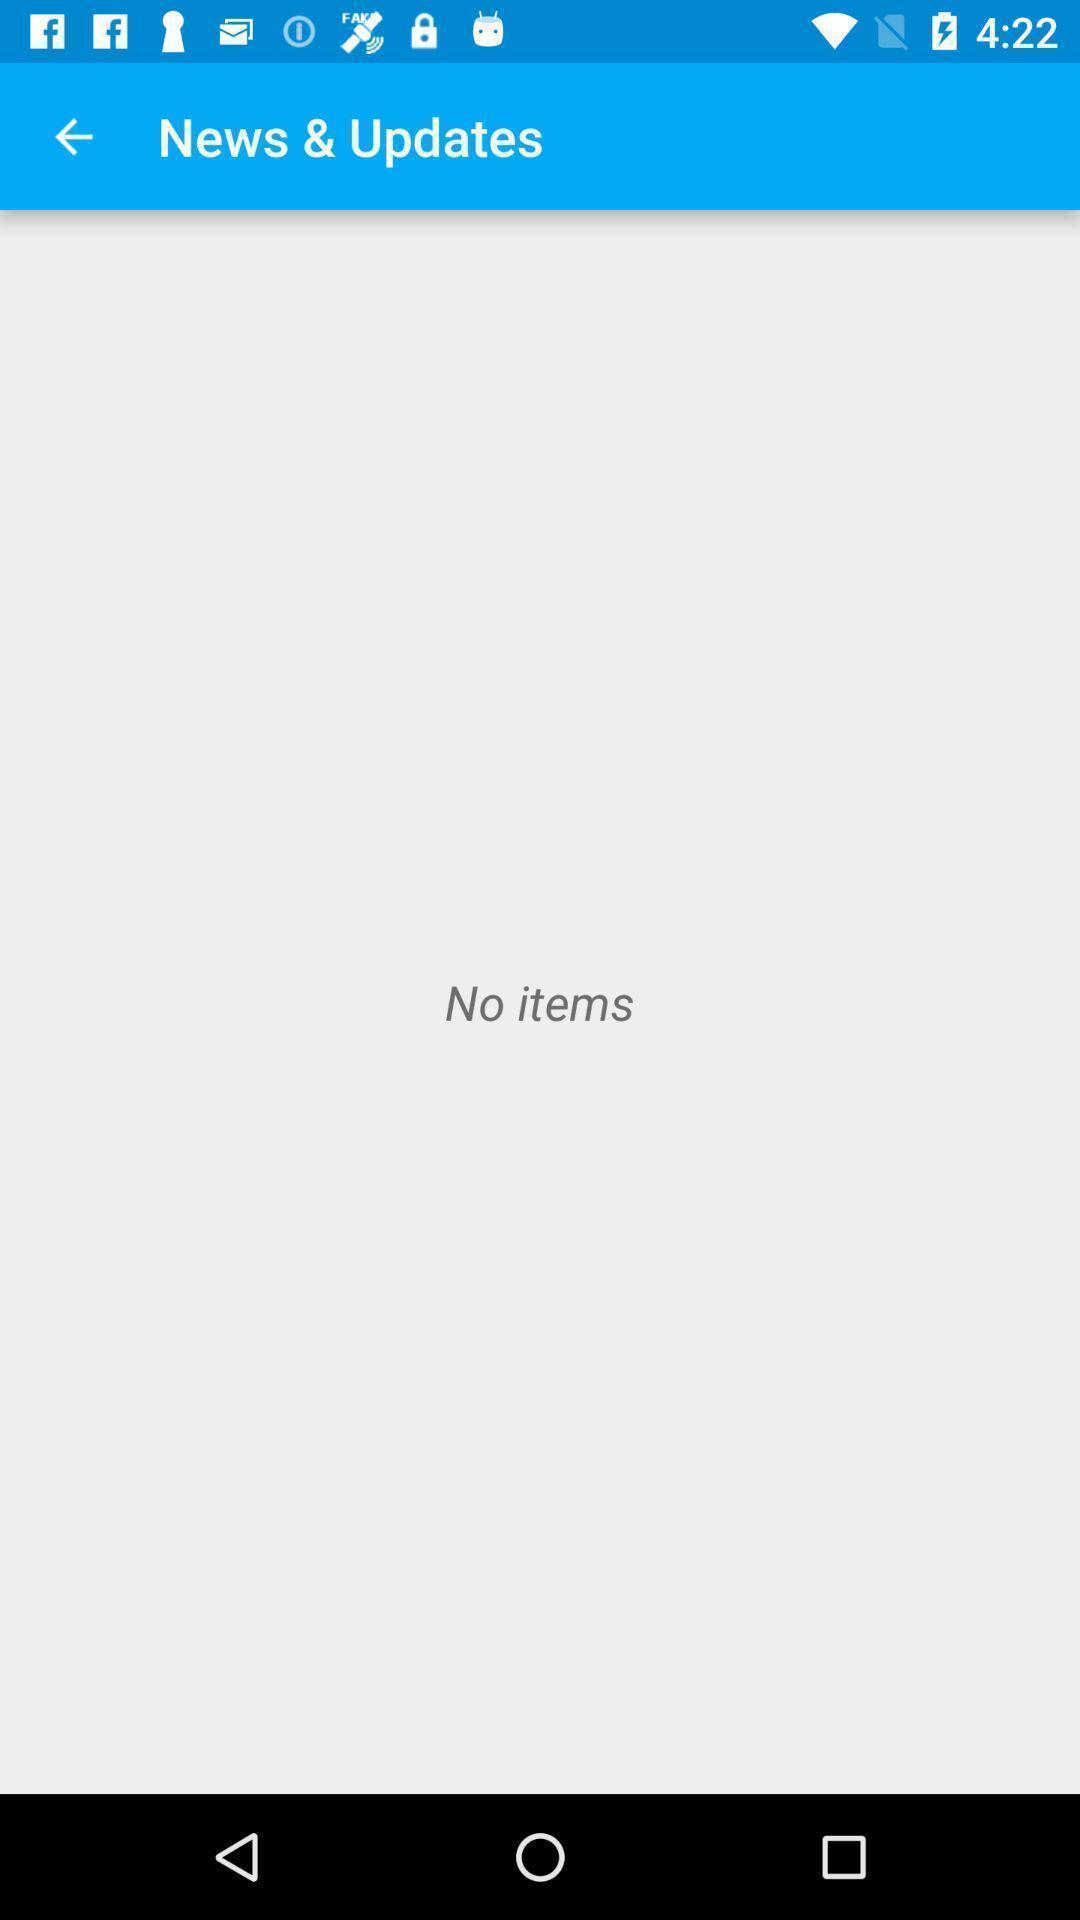Explain the elements present in this screenshot. Screen displaying news and updates page. 